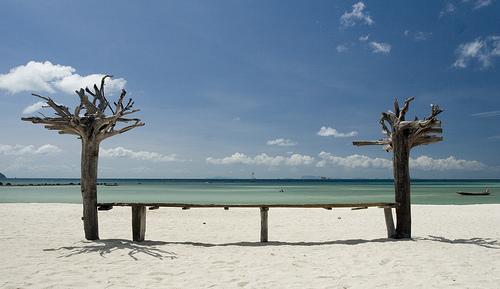What's the weather?
Concise answer only. Sunny. How many dead trees are there?
Answer briefly. 2. Is this a beach or ocean?
Be succinct. Beach. What time of year was this picture taken?
Short answer required. Summer. 